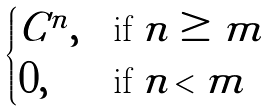<formula> <loc_0><loc_0><loc_500><loc_500>\begin{cases} C ^ { n } , & \text {if $n \geq m$} \\ 0 , & \text {if $n < m$} \end{cases}</formula> 